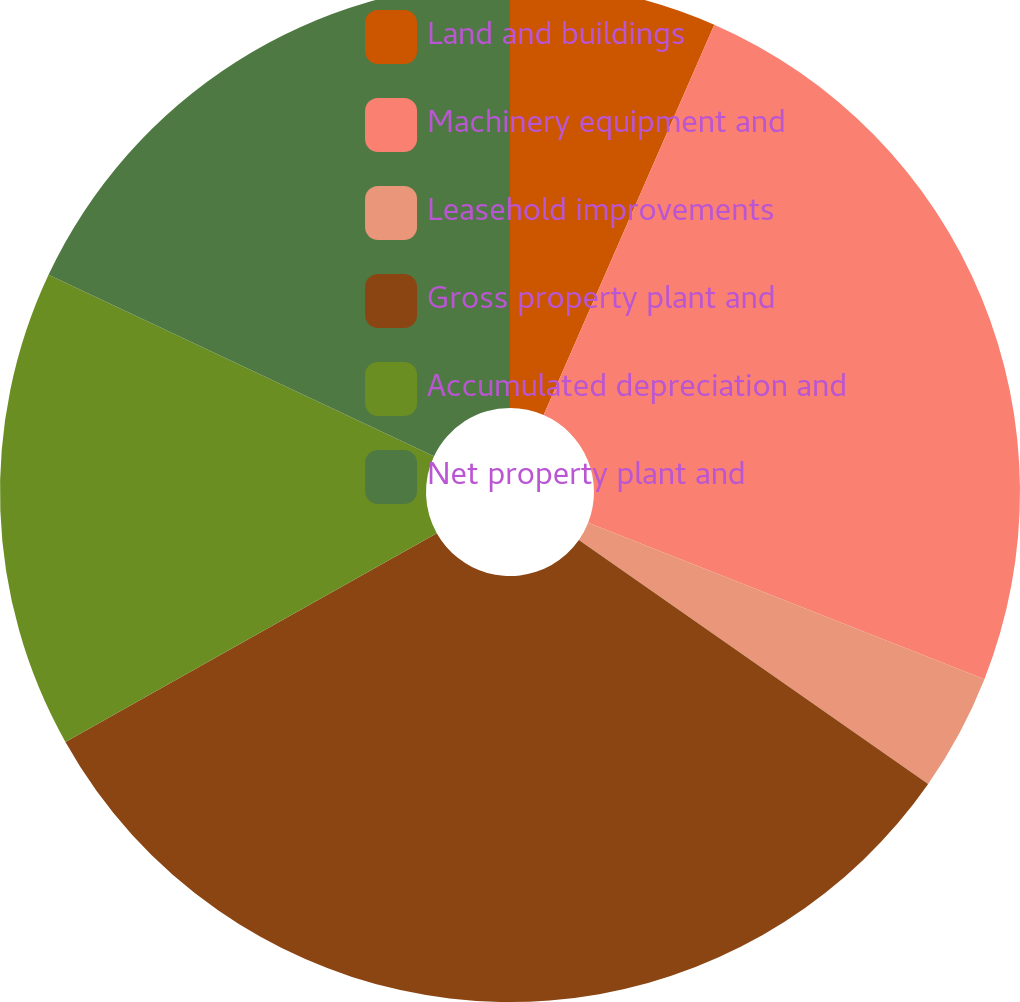<chart> <loc_0><loc_0><loc_500><loc_500><pie_chart><fcel>Land and buildings<fcel>Machinery equipment and<fcel>Leasehold improvements<fcel>Gross property plant and<fcel>Accumulated depreciation and<fcel>Net property plant and<nl><fcel>6.56%<fcel>24.42%<fcel>3.72%<fcel>32.15%<fcel>15.15%<fcel>18.0%<nl></chart> 